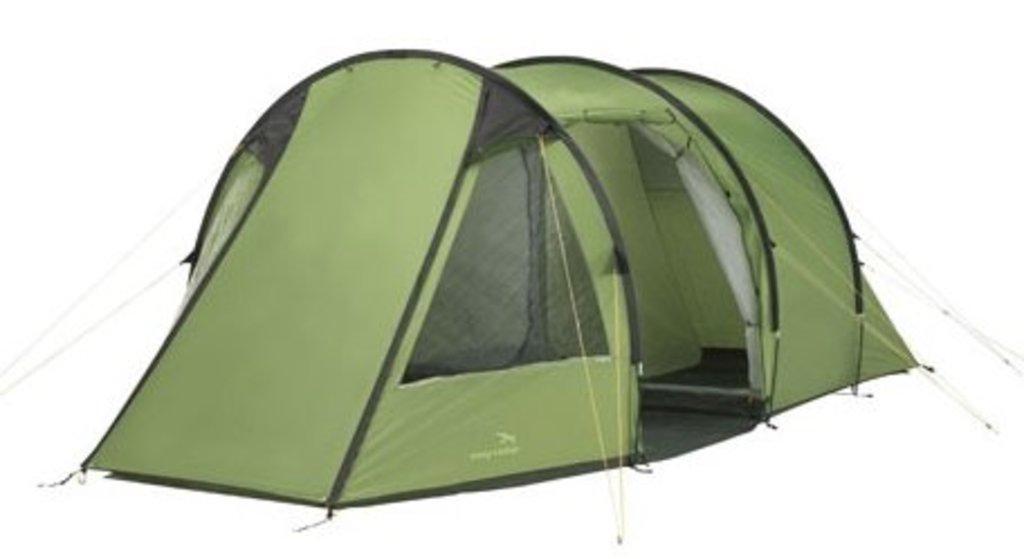Can you describe this image briefly? In this picture there is a tent in the center of the image, which is red in color. 